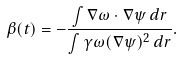Convert formula to latex. <formula><loc_0><loc_0><loc_500><loc_500>\beta ( t ) = - \frac { \int \nabla \omega \cdot \nabla \psi \, d { r } } { \int \gamma \omega ( \nabla \psi ) ^ { 2 } \, d { r } } .</formula> 